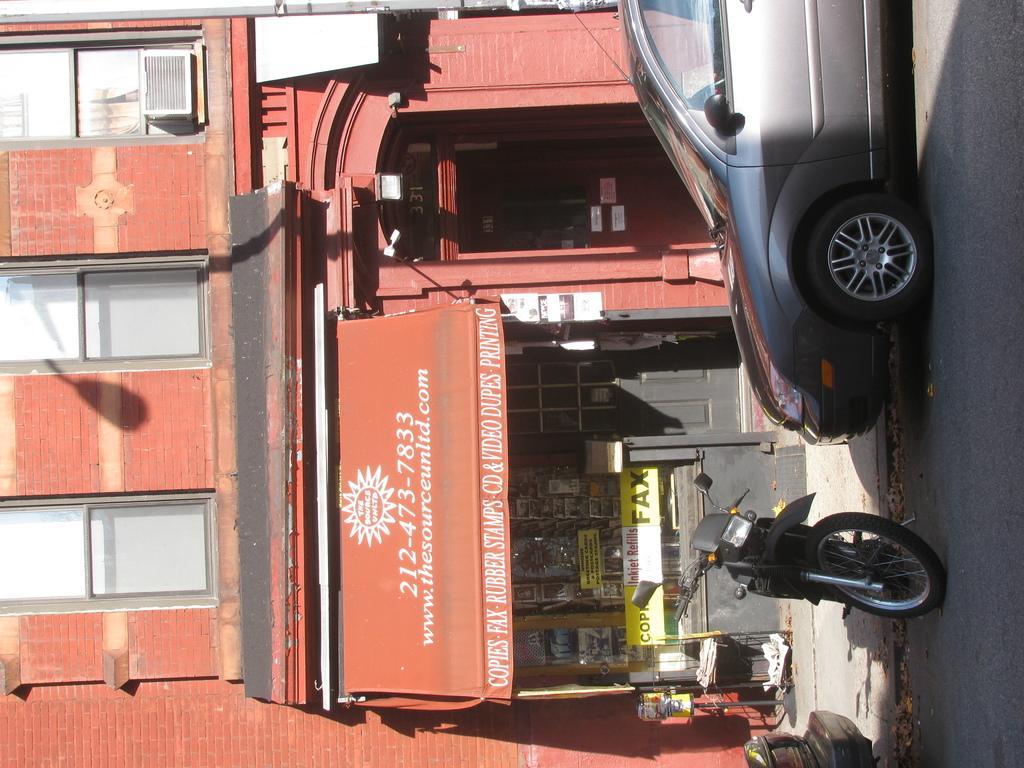In one or two sentences, can you explain what this image depicts? In this image there is a car at top right side of this image and there is a bike at bottom right side of this image. and there is a building at left side of this image. as we can see there is a shop in middle of this image. 